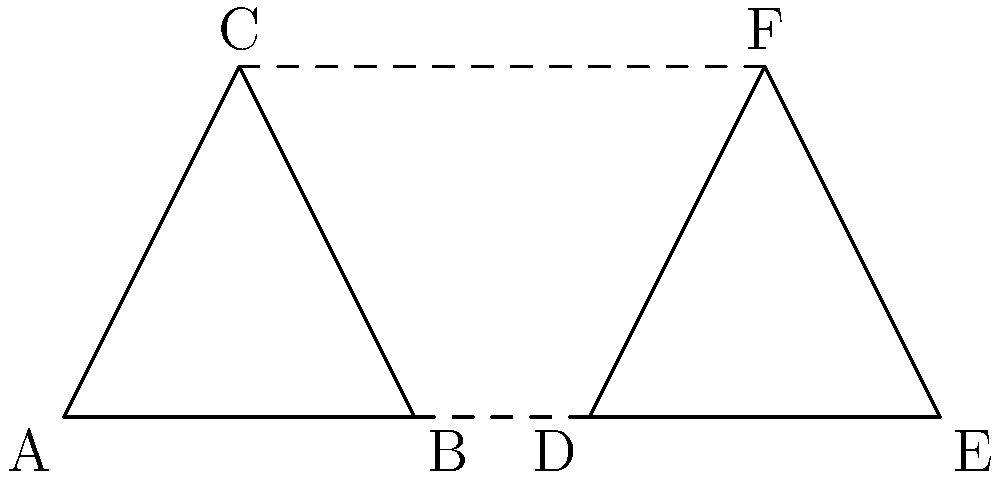A Texas rancher wants to design a new cattle brand using two congruent triangles. The brand will be made up of triangles ABC and DEF as shown in the diagram. If AB = 2 inches, BC = 2.24 inches, and the distance between corresponding points of the triangles (AD, BE, and CF) is 3 inches, what is the area of the entire brand in square inches? Let's solve this step-by-step:

1) First, we need to find the area of one triangle. We can use Heron's formula:
   $A = \sqrt{s(s-a)(s-b)(s-c)}$, where $s = \frac{a+b+c}{2}$ (semi-perimeter)

2) We know AB = 2 inches and BC = 2.24 inches. We need to find AC:
   Using the Pythagorean theorem in the right triangle formed by the altitude from C:
   $AC^2 = 1^2 + 2^2 = 5$
   $AC = \sqrt{5} = 2.236$ inches

3) Now we can calculate the semi-perimeter:
   $s = \frac{2 + 2.24 + 2.236}{2} = 3.238$ inches

4) Apply Heron's formula:
   $A = \sqrt{3.238(3.238-2)(3.238-2.24)(3.238-2.236)}$
   $A = \sqrt{3.238 \times 1.238 \times 0.998 \times 1.002}$
   $A = \sqrt{4.0} = 2$ square inches

5) The brand consists of two congruent triangles, so the total area would be:
   Total Area = $2 \times 2 = 4$ square inches

Therefore, the area of the entire brand is 4 square inches.
Answer: 4 square inches 